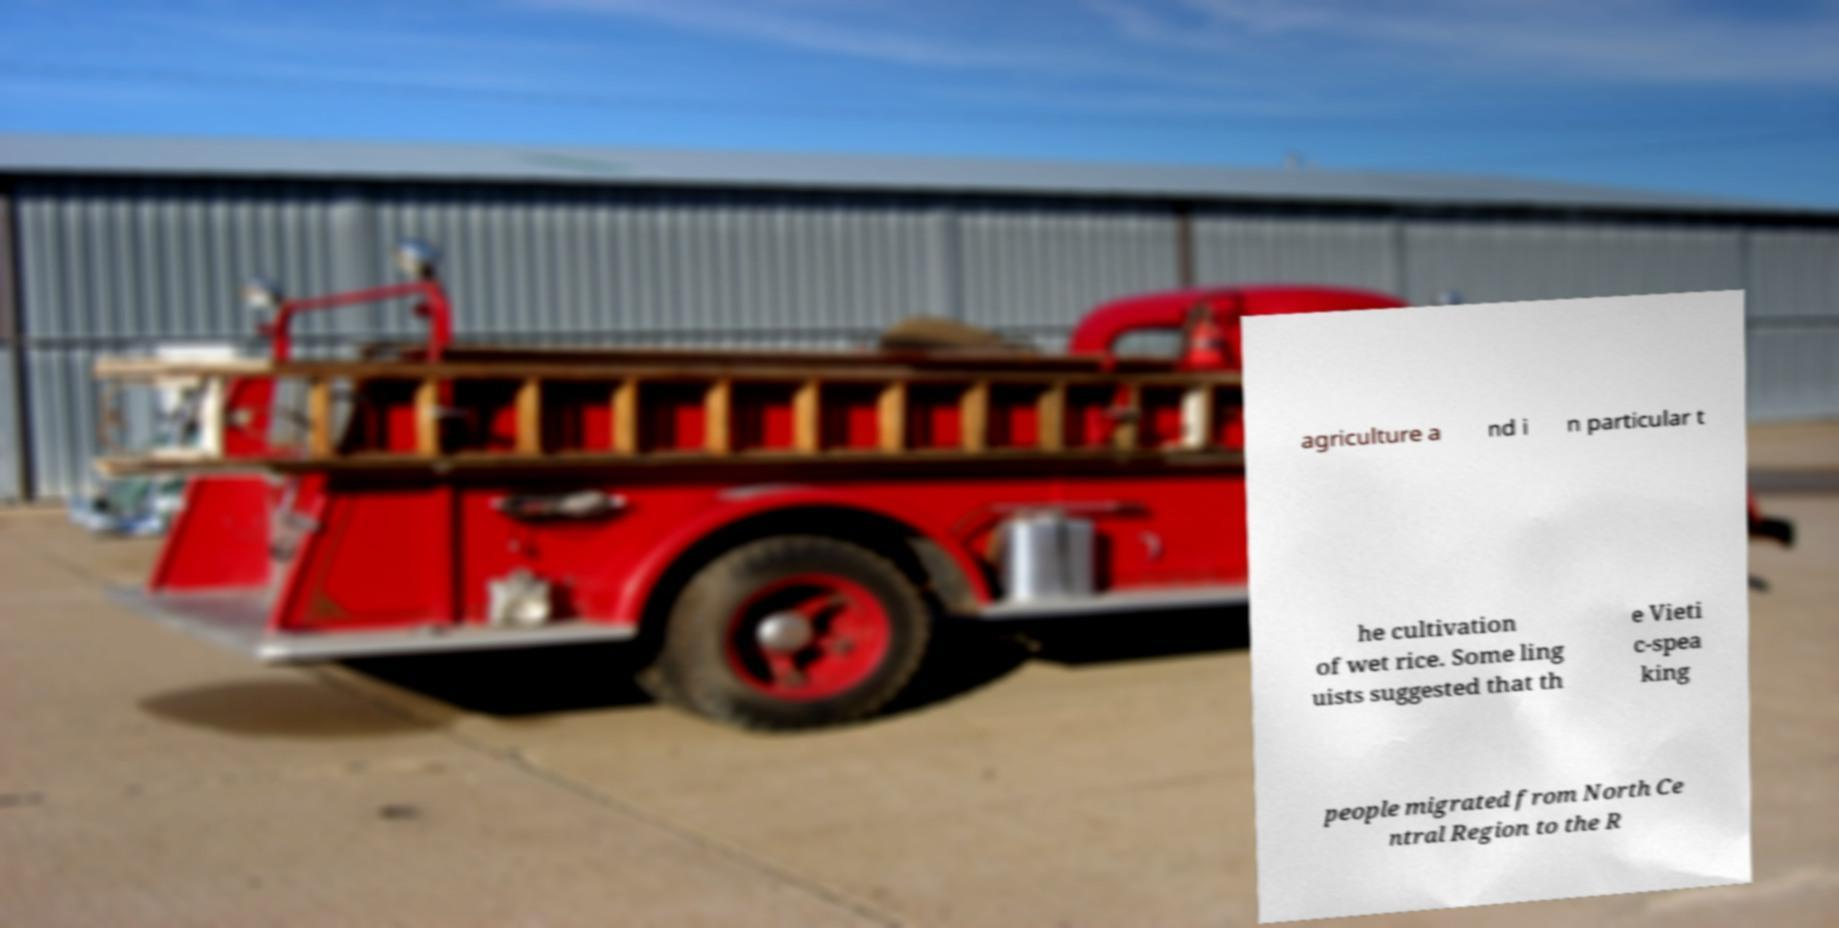Can you accurately transcribe the text from the provided image for me? agriculture a nd i n particular t he cultivation of wet rice. Some ling uists suggested that th e Vieti c-spea king people migrated from North Ce ntral Region to the R 